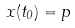Convert formula to latex. <formula><loc_0><loc_0><loc_500><loc_500>x ( t _ { 0 } ) = p</formula> 